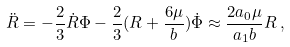<formula> <loc_0><loc_0><loc_500><loc_500>\ddot { R } = - \frac { 2 } { 3 } \dot { R } \Phi - \frac { 2 } { 3 } ( R + \frac { 6 \mu } { b } ) \dot { \Phi } \approx \frac { 2 a _ { 0 } \mu } { a _ { 1 } b } R \, ,</formula> 